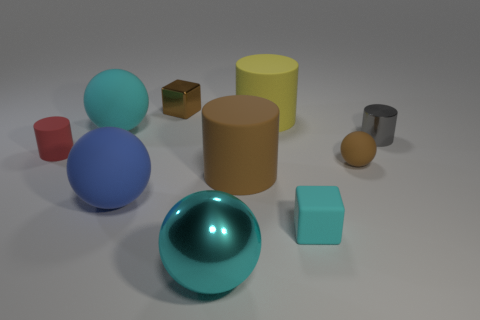Subtract 1 cylinders. How many cylinders are left? 3 Subtract all cylinders. How many objects are left? 6 Add 5 big metallic things. How many big metallic things are left? 6 Add 4 small cyan things. How many small cyan things exist? 5 Subtract 0 green cubes. How many objects are left? 10 Subtract all large green matte blocks. Subtract all cyan metallic balls. How many objects are left? 9 